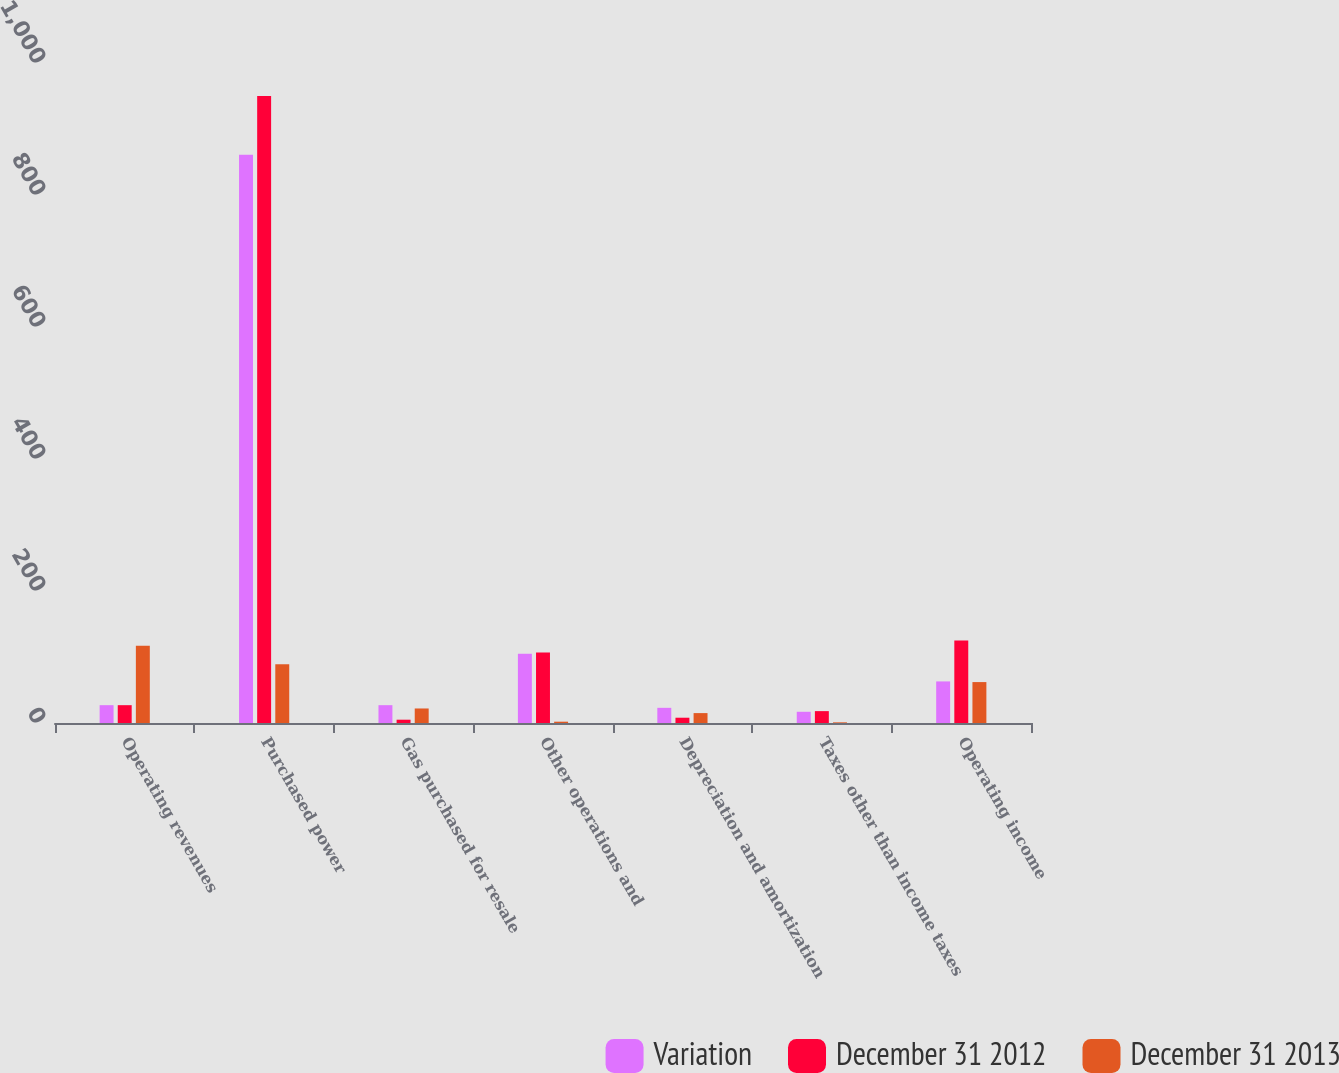Convert chart to OTSL. <chart><loc_0><loc_0><loc_500><loc_500><stacked_bar_chart><ecel><fcel>Operating revenues<fcel>Purchased power<fcel>Gas purchased for resale<fcel>Other operations and<fcel>Depreciation and amortization<fcel>Taxes other than income taxes<fcel>Operating income<nl><fcel>Variation<fcel>27<fcel>861<fcel>27<fcel>105<fcel>23<fcel>17<fcel>63<nl><fcel>December 31 2012<fcel>27<fcel>950<fcel>5<fcel>107<fcel>8<fcel>18<fcel>125<nl><fcel>December 31 2013<fcel>117<fcel>89<fcel>22<fcel>2<fcel>15<fcel>1<fcel>62<nl></chart> 